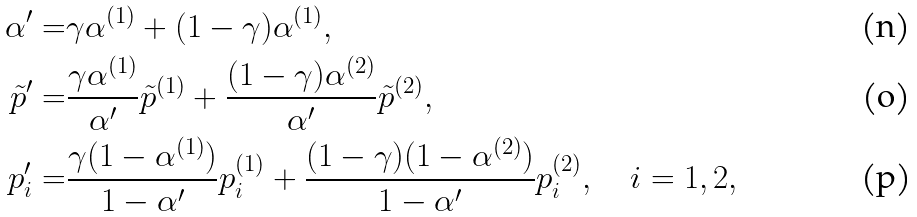<formula> <loc_0><loc_0><loc_500><loc_500>\alpha ^ { \prime } = & \gamma \alpha ^ { ( 1 ) } + ( 1 - \gamma ) \alpha ^ { ( 1 ) } , \\ \tilde { p } ^ { \prime } = & \frac { \gamma \alpha ^ { ( 1 ) } } { \alpha ^ { \prime } } \tilde { p } ^ { ( 1 ) } + \frac { ( 1 - \gamma ) \alpha ^ { ( 2 ) } } { \alpha ^ { \prime } } \tilde { p } ^ { ( 2 ) } , \\ p _ { i } ^ { \prime } = & \frac { \gamma ( 1 - \alpha ^ { ( 1 ) } ) } { 1 - \alpha ^ { \prime } } { p } _ { i } ^ { ( 1 ) } + \frac { ( 1 - \gamma ) ( 1 - \alpha ^ { ( 2 ) } ) } { 1 - \alpha ^ { \prime } } { p } _ { i } ^ { ( 2 ) } , \quad i = 1 , 2 ,</formula> 